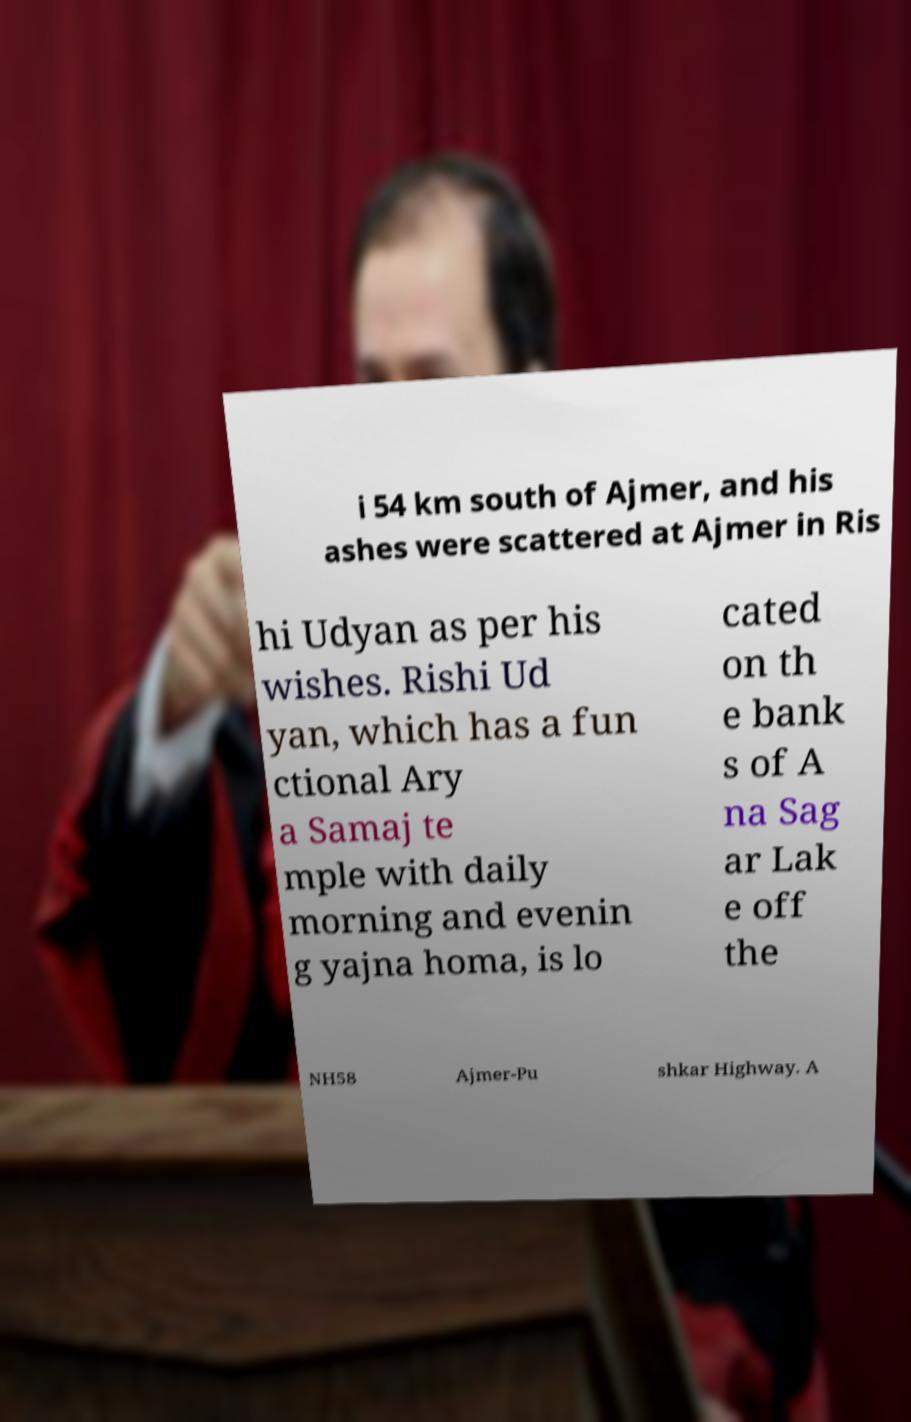There's text embedded in this image that I need extracted. Can you transcribe it verbatim? i 54 km south of Ajmer, and his ashes were scattered at Ajmer in Ris hi Udyan as per his wishes. Rishi Ud yan, which has a fun ctional Ary a Samaj te mple with daily morning and evenin g yajna homa, is lo cated on th e bank s of A na Sag ar Lak e off the NH58 Ajmer-Pu shkar Highway. A 